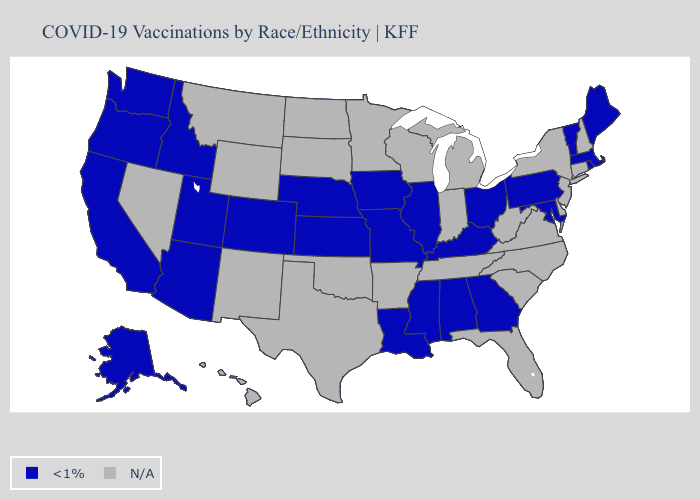Name the states that have a value in the range N/A?
Give a very brief answer. Arkansas, Connecticut, Delaware, Florida, Hawaii, Indiana, Michigan, Minnesota, Montana, Nevada, New Hampshire, New Jersey, New Mexico, New York, North Carolina, North Dakota, Oklahoma, South Carolina, South Dakota, Tennessee, Texas, Virginia, West Virginia, Wisconsin, Wyoming. Name the states that have a value in the range N/A?
Give a very brief answer. Arkansas, Connecticut, Delaware, Florida, Hawaii, Indiana, Michigan, Minnesota, Montana, Nevada, New Hampshire, New Jersey, New Mexico, New York, North Carolina, North Dakota, Oklahoma, South Carolina, South Dakota, Tennessee, Texas, Virginia, West Virginia, Wisconsin, Wyoming. What is the value of Rhode Island?
Answer briefly. <1%. Does the map have missing data?
Be succinct. Yes. What is the value of Michigan?
Quick response, please. N/A. Name the states that have a value in the range N/A?
Answer briefly. Arkansas, Connecticut, Delaware, Florida, Hawaii, Indiana, Michigan, Minnesota, Montana, Nevada, New Hampshire, New Jersey, New Mexico, New York, North Carolina, North Dakota, Oklahoma, South Carolina, South Dakota, Tennessee, Texas, Virginia, West Virginia, Wisconsin, Wyoming. Name the states that have a value in the range N/A?
Short answer required. Arkansas, Connecticut, Delaware, Florida, Hawaii, Indiana, Michigan, Minnesota, Montana, Nevada, New Hampshire, New Jersey, New Mexico, New York, North Carolina, North Dakota, Oklahoma, South Carolina, South Dakota, Tennessee, Texas, Virginia, West Virginia, Wisconsin, Wyoming. What is the lowest value in the Northeast?
Be succinct. <1%. How many symbols are there in the legend?
Give a very brief answer. 2. What is the value of Nebraska?
Keep it brief. <1%. What is the highest value in states that border New Hampshire?
Keep it brief. <1%. What is the value of Maine?
Give a very brief answer. <1%. Which states have the highest value in the USA?
Concise answer only. Alabama, Alaska, Arizona, California, Colorado, Georgia, Idaho, Illinois, Iowa, Kansas, Kentucky, Louisiana, Maine, Maryland, Massachusetts, Mississippi, Missouri, Nebraska, Ohio, Oregon, Pennsylvania, Rhode Island, Utah, Vermont, Washington. 